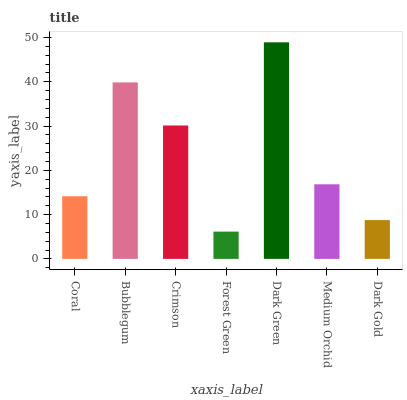Is Forest Green the minimum?
Answer yes or no. Yes. Is Dark Green the maximum?
Answer yes or no. Yes. Is Bubblegum the minimum?
Answer yes or no. No. Is Bubblegum the maximum?
Answer yes or no. No. Is Bubblegum greater than Coral?
Answer yes or no. Yes. Is Coral less than Bubblegum?
Answer yes or no. Yes. Is Coral greater than Bubblegum?
Answer yes or no. No. Is Bubblegum less than Coral?
Answer yes or no. No. Is Medium Orchid the high median?
Answer yes or no. Yes. Is Medium Orchid the low median?
Answer yes or no. Yes. Is Dark Gold the high median?
Answer yes or no. No. Is Forest Green the low median?
Answer yes or no. No. 